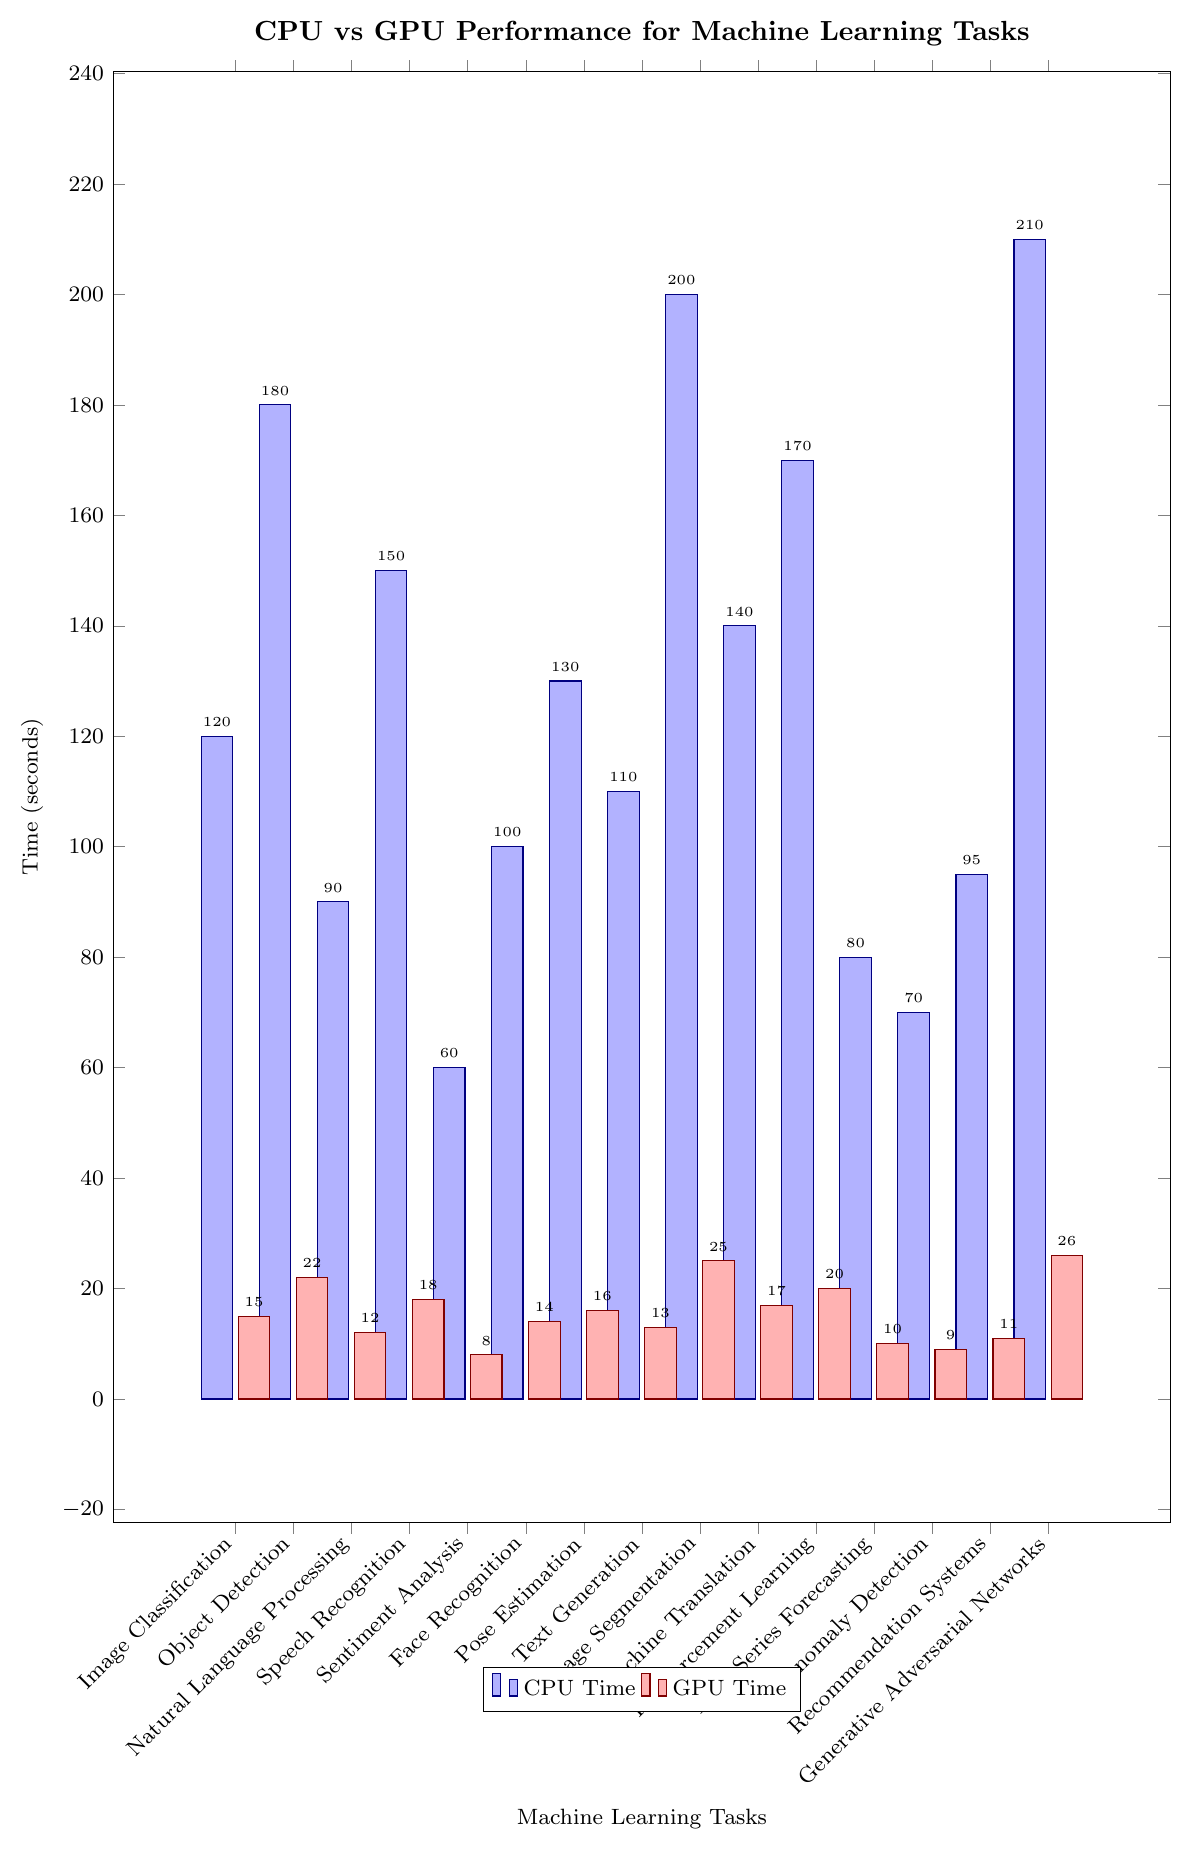Which task has the shortest processing time on the GPU? To find the task with the shortest GPU processing time, visually scan the red bars in the chart for the smallest height. The shortest red bar corresponds to the task "Sentiment Analysis" with a time of 8 seconds.
Answer: Sentiment Analysis What is the difference in CPU processing time between "Image Segmentation" and "Object Detection"? To calculate the difference in CPU processing time between "Image Segmentation" and "Object Detection," look at the heights of both blue bars. "Image Segmentation" has a time of 200 seconds, and "Object Detection" is 180 seconds. The difference is 200 - 180 = 20 seconds.
Answer: 20 seconds Which machine learning task has the largest difference in processing time between CPU and GPU? To find the task with the largest difference, calculate the differences for each task by subtracting GPU time from CPU time, then identify the maximum value. The differences are 105, 158, 78, 132, 52, 86, 114, 97, 175, 123, 150, 70, 61, 84, and 184 seconds respectively. The largest difference is 184 seconds for "Generative Adversarial Networks".
Answer: Generative Adversarial Networks What is the average GPU processing time across all tasks? To find the average GPU time, sum all the GPU times and divide by the number of tasks. The sum is 15 + 22 + 12 + 18 + 8 + 14 + 16 + 13 + 25 + 17 + 20 + 10 + 9 + 11 + 26 = 236 seconds. There are 15 tasks, so the average GPU time is 236 / 15 ≈ 15.73 seconds.
Answer: 15.73 seconds How many tasks have a CPU time greater than 150 seconds? To count the number of tasks with a CPU time greater than 150 seconds, identify the blue bars exceeding this value. The tasks are "Object Detection" (180s), "Speech Recognition" (150s), "Image Segmentation" (200s), "Reinforcement Learning" (170s), and "Generative Adversarial Networks" (210s). Note that "Speech Recognition" is equal to 150s, so it is not counted. Thus, the total is 4 tasks.
Answer: 4 What is the total CPU processing time for "Face Recognition", "Pose Estimation", and "Text Generation"? Sum the CPU times for the mentioned tasks. "Face Recognition" has 100 seconds, "Pose Estimation" has 130 seconds, and "Text Generation" has 110 seconds. The total is 100 + 130 + 110 = 340 seconds.
Answer: 340 seconds Which color represents the GPU time in the plot? Identify the color associated with the GPU time by looking at the legend in the chart. The tasks associated with the GPU have red-colored bars.
Answer: Red Which task has the same processing time on the CPU as "Speech Recognition" on the GPU? Find "Speech Recognition" on the GPU, which is 18 seconds. Compare this with the CPU times and find one with a matching value. No CPU times are exactly 18 seconds, so none of the tasks meet this condition.
Answer: None What proportion of the total CPU time is spent on "Generative Adversarial Networks"? Calculate the proportion of the total CPU time spent on "Generative Adversarial Networks". The total CPU time is 120 + 180 + 90 + 150 + 60 + 100 + 130 + 110 + 200 + 140 + 170 + 80 + 70 + 95 + 210 = 1905 seconds. The time for "Generative Adversarial Networks" is 210 seconds. Therefore, the proportion is 210 / 1905 ≈ 0.11.
Answer: 0.11 